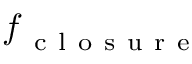<formula> <loc_0><loc_0><loc_500><loc_500>f _ { c l o s u r e }</formula> 